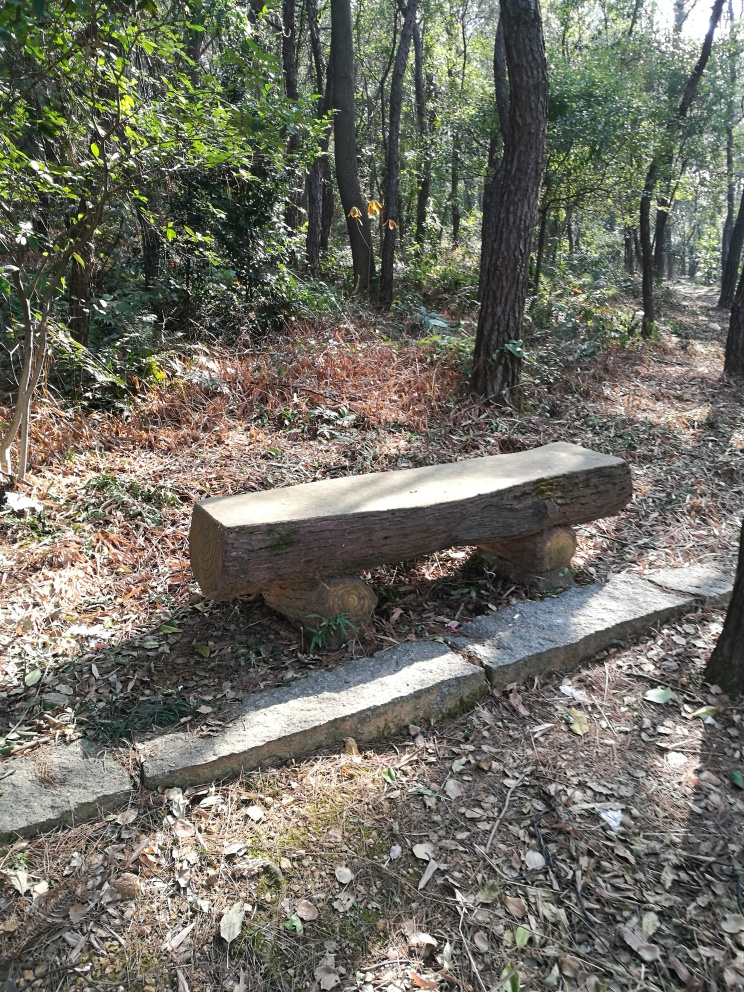What could be the purpose of the wooden bench in this location? The wooden bench is strategically placed amidst the trees, likely providing a restful spot for walkers to sit and enjoy the tranquility of the natural surroundings. It's a simple amenity to enhance visitors' experience of the forest. Is the bench made from materials found in the forest? It's quite possible that the bench is crafted from timber sourced within the same forest, which would reflect a sustainable use of local resources. Its rustic design suggests an effort to maintain harmony with the natural environment. 